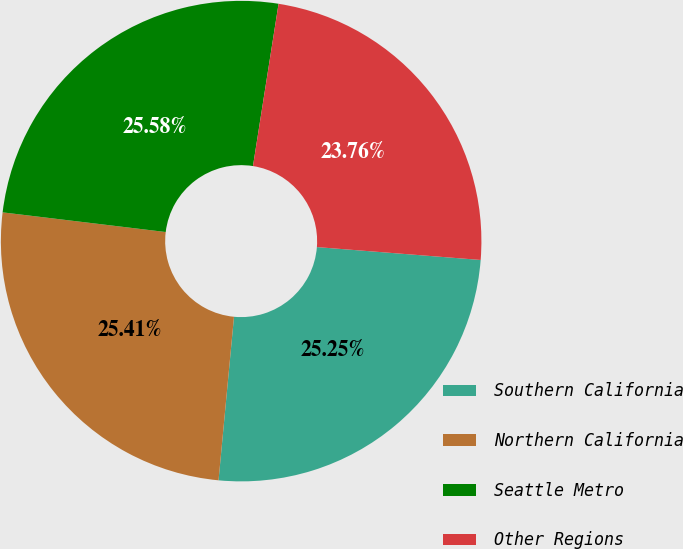Convert chart. <chart><loc_0><loc_0><loc_500><loc_500><pie_chart><fcel>Southern California<fcel>Northern California<fcel>Seattle Metro<fcel>Other Regions<nl><fcel>25.25%<fcel>25.41%<fcel>25.58%<fcel>23.76%<nl></chart> 